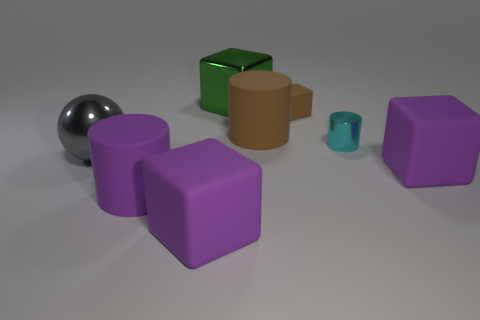Subtract all green blocks. How many blocks are left? 3 Subtract 1 cylinders. How many cylinders are left? 2 Subtract all matte cubes. How many cubes are left? 1 Subtract all yellow cubes. Subtract all red spheres. How many cubes are left? 4 Add 1 purple cylinders. How many objects exist? 9 Subtract all balls. How many objects are left? 7 Add 2 shiny things. How many shiny things are left? 5 Add 1 large cylinders. How many large cylinders exist? 3 Subtract 0 yellow balls. How many objects are left? 8 Subtract all big brown rubber blocks. Subtract all gray shiny things. How many objects are left? 7 